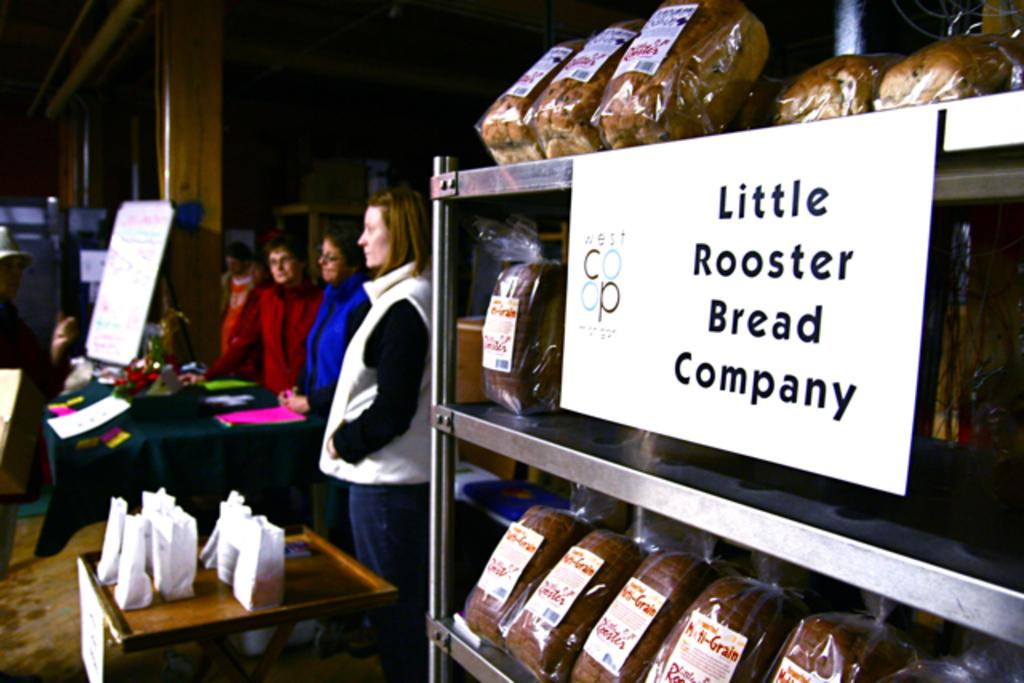What can be seen in the image? There are women standing in the image. Where are the women positioned in relation to the table? The women are standing in front of a table. What is on the table? There is a notice board on the table. How many seeds are on the table in the image? There are no seeds present on the table in the image. 